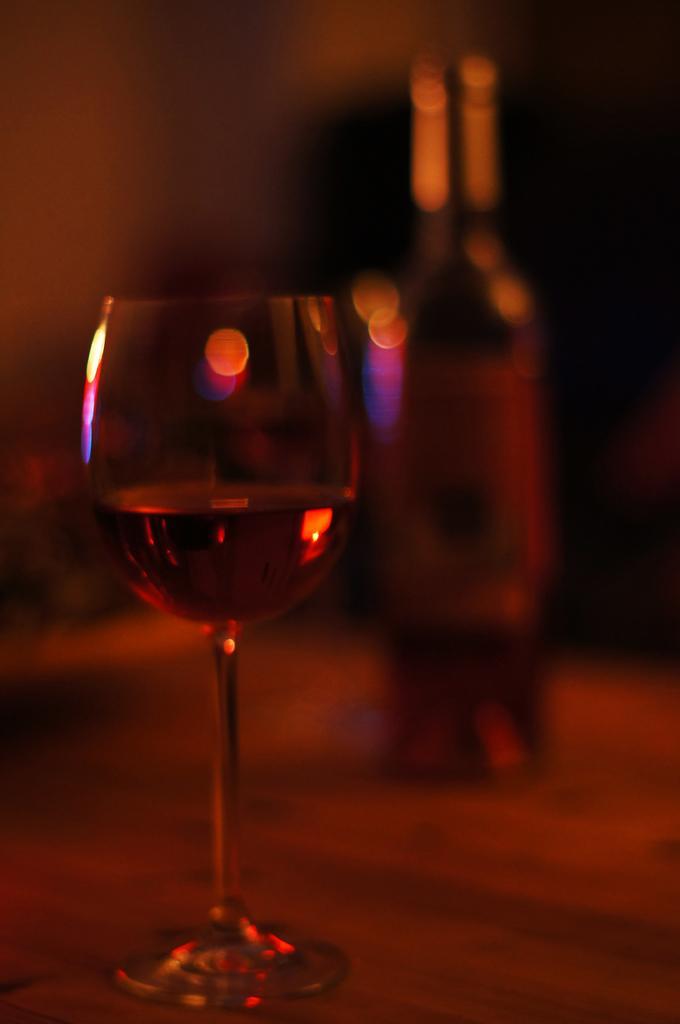In one or two sentences, can you explain what this image depicts? In this image, on the left side, we can see a glass with some drink. On the right side, we can see a bottle. In the background, we can see black color. 